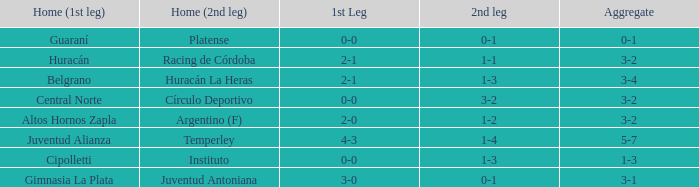Who played at home for the 2nd leg with a score of 1-2? Argentino (F). Can you parse all the data within this table? {'header': ['Home (1st leg)', 'Home (2nd leg)', '1st Leg', '2nd leg', 'Aggregate'], 'rows': [['Guaraní', 'Platense', '0-0', '0-1', '0-1'], ['Huracán', 'Racing de Córdoba', '2-1', '1-1', '3-2'], ['Belgrano', 'Huracán La Heras', '2-1', '1-3', '3-4'], ['Central Norte', 'Círculo Deportivo', '0-0', '3-2', '3-2'], ['Altos Hornos Zapla', 'Argentino (F)', '2-0', '1-2', '3-2'], ['Juventud Alianza', 'Temperley', '4-3', '1-4', '5-7'], ['Cipolletti', 'Instituto', '0-0', '1-3', '1-3'], ['Gimnasia La Plata', 'Juventud Antoniana', '3-0', '0-1', '3-1']]} 